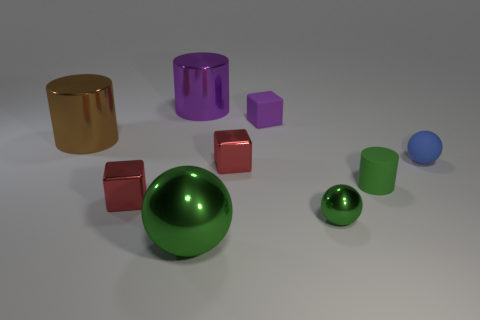Add 1 green rubber objects. How many objects exist? 10 Subtract all balls. How many objects are left? 6 Subtract all small brown metal cylinders. Subtract all tiny blocks. How many objects are left? 6 Add 1 large brown cylinders. How many large brown cylinders are left? 2 Add 7 small red metallic things. How many small red metallic things exist? 9 Subtract 1 purple cylinders. How many objects are left? 8 